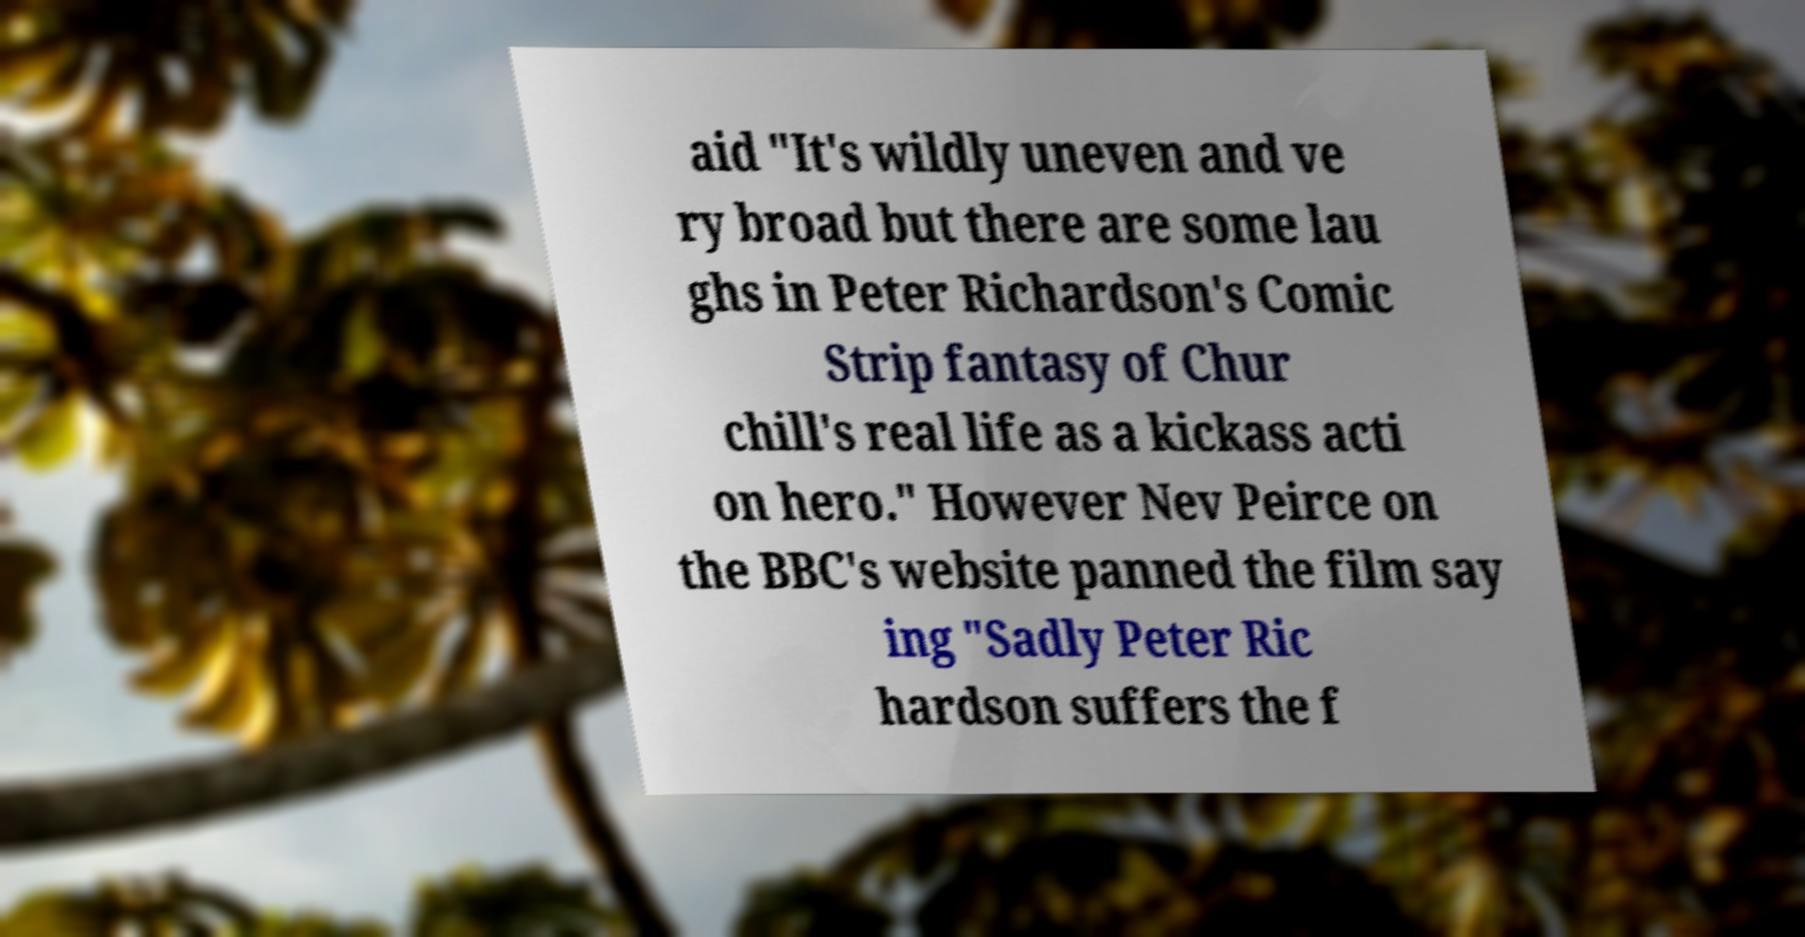Please identify and transcribe the text found in this image. aid "It's wildly uneven and ve ry broad but there are some lau ghs in Peter Richardson's Comic Strip fantasy of Chur chill's real life as a kickass acti on hero." However Nev Peirce on the BBC's website panned the film say ing "Sadly Peter Ric hardson suffers the f 